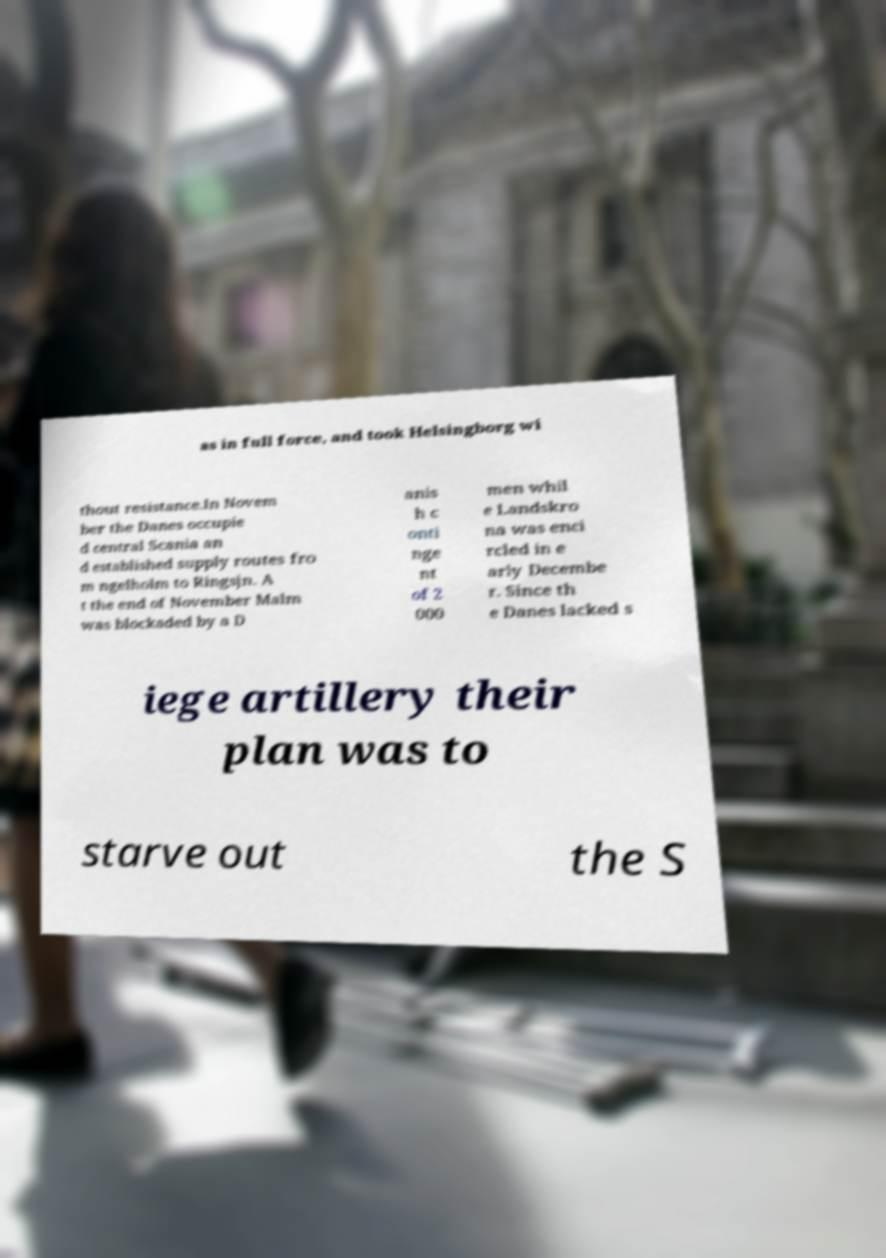Can you accurately transcribe the text from the provided image for me? as in full force, and took Helsingborg wi thout resistance.In Novem ber the Danes occupie d central Scania an d established supply routes fro m ngelholm to Ringsjn. A t the end of November Malm was blockaded by a D anis h c onti nge nt of 2 000 men whil e Landskro na was enci rcled in e arly Decembe r. Since th e Danes lacked s iege artillery their plan was to starve out the S 